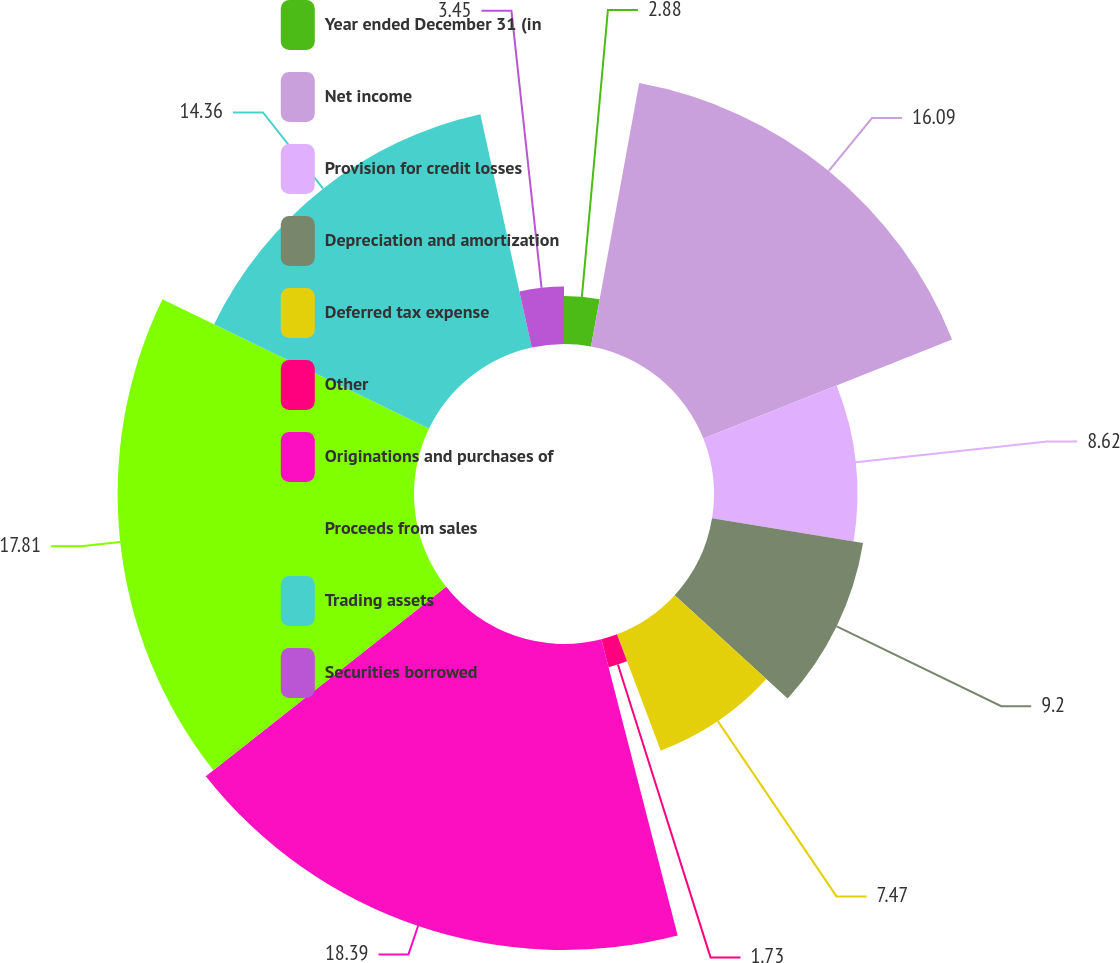Convert chart. <chart><loc_0><loc_0><loc_500><loc_500><pie_chart><fcel>Year ended December 31 (in<fcel>Net income<fcel>Provision for credit losses<fcel>Depreciation and amortization<fcel>Deferred tax expense<fcel>Other<fcel>Originations and purchases of<fcel>Proceeds from sales<fcel>Trading assets<fcel>Securities borrowed<nl><fcel>2.88%<fcel>16.09%<fcel>8.62%<fcel>9.2%<fcel>7.47%<fcel>1.73%<fcel>18.39%<fcel>17.81%<fcel>14.36%<fcel>3.45%<nl></chart> 